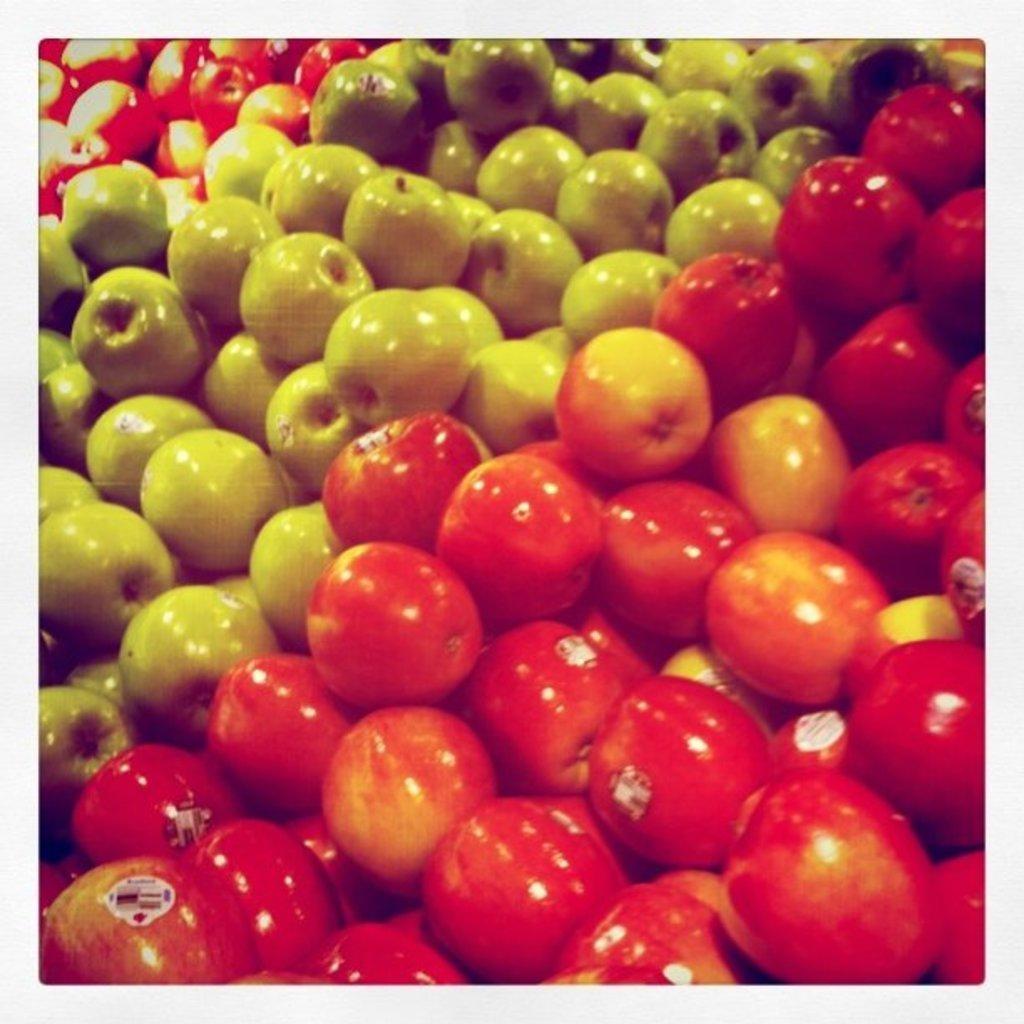Could you give a brief overview of what you see in this image? This is an edited image. I can see the bunches of red apples and green apples. 